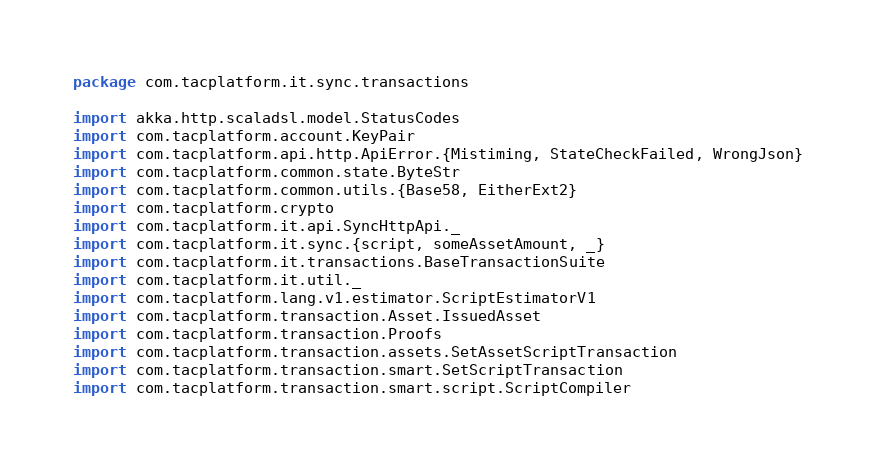Convert code to text. <code><loc_0><loc_0><loc_500><loc_500><_Scala_>package com.tacplatform.it.sync.transactions

import akka.http.scaladsl.model.StatusCodes
import com.tacplatform.account.KeyPair
import com.tacplatform.api.http.ApiError.{Mistiming, StateCheckFailed, WrongJson}
import com.tacplatform.common.state.ByteStr
import com.tacplatform.common.utils.{Base58, EitherExt2}
import com.tacplatform.crypto
import com.tacplatform.it.api.SyncHttpApi._
import com.tacplatform.it.sync.{script, someAssetAmount, _}
import com.tacplatform.it.transactions.BaseTransactionSuite
import com.tacplatform.it.util._
import com.tacplatform.lang.v1.estimator.ScriptEstimatorV1
import com.tacplatform.transaction.Asset.IssuedAsset
import com.tacplatform.transaction.Proofs
import com.tacplatform.transaction.assets.SetAssetScriptTransaction
import com.tacplatform.transaction.smart.SetScriptTransaction
import com.tacplatform.transaction.smart.script.ScriptCompiler</code> 